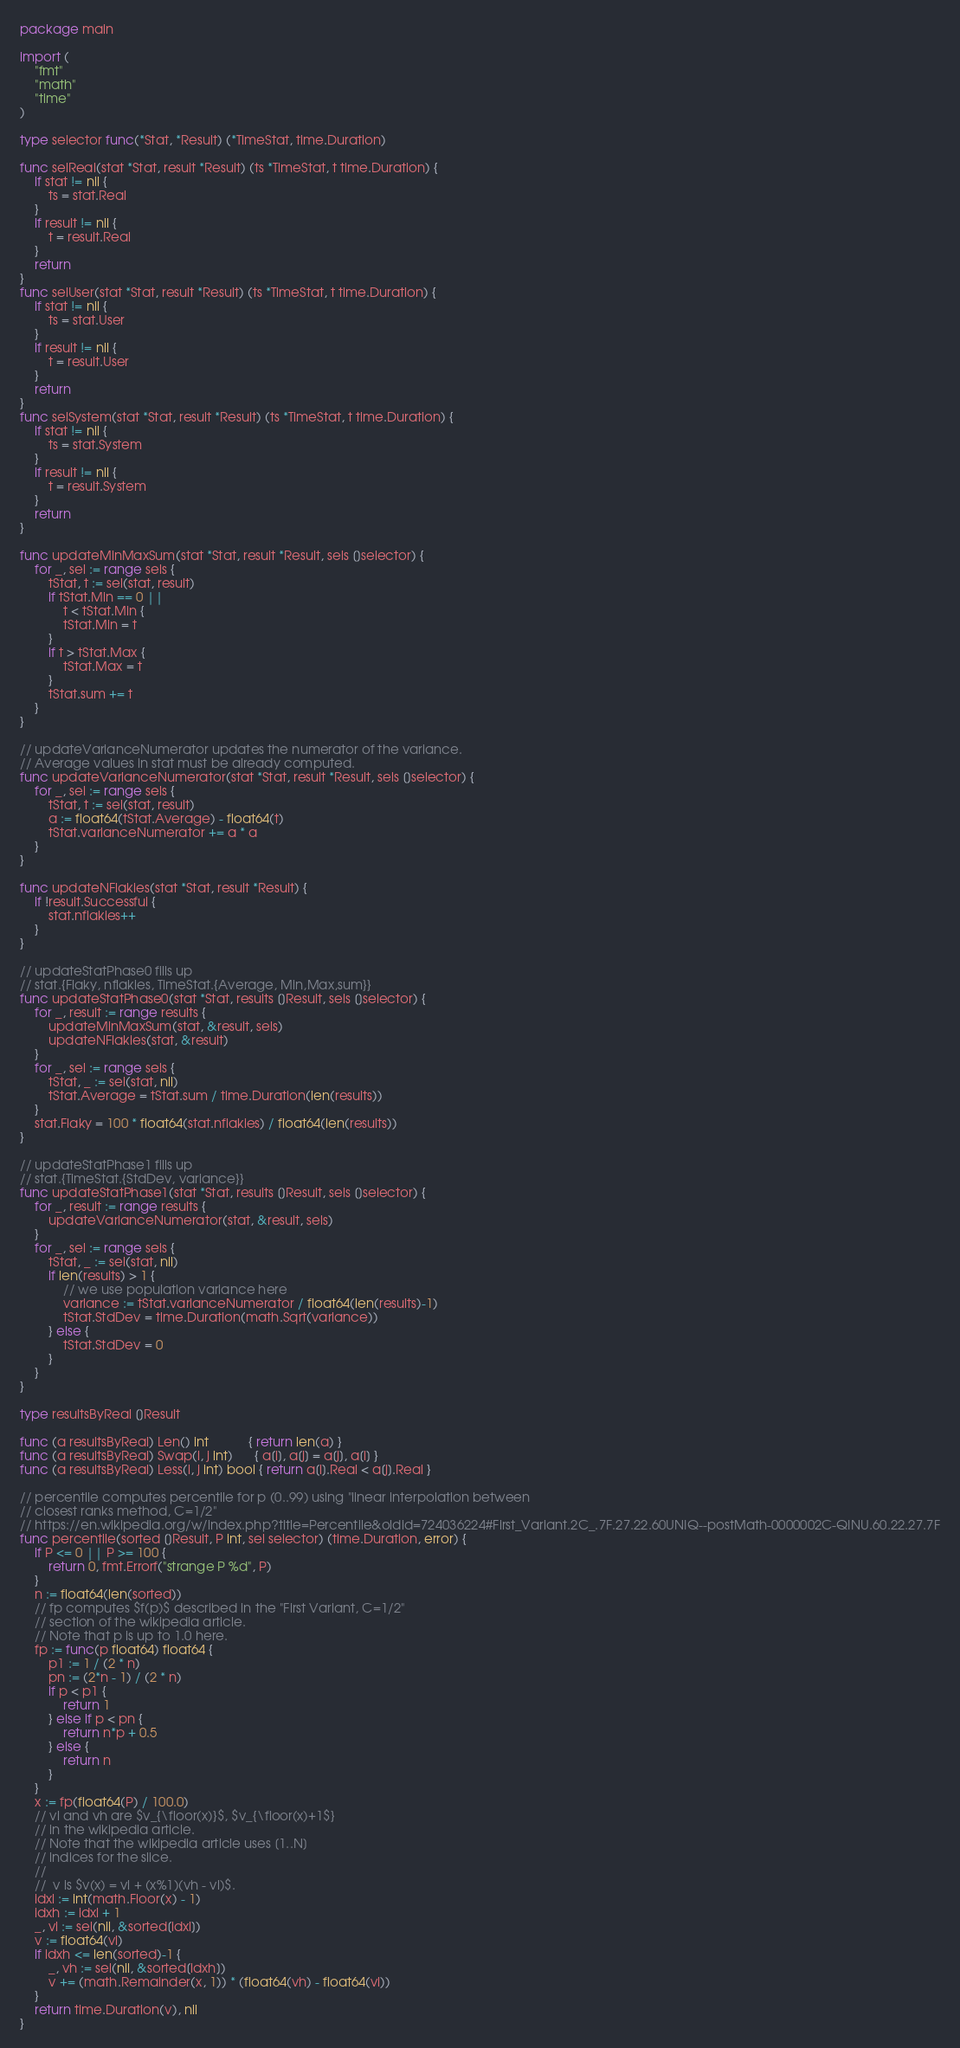<code> <loc_0><loc_0><loc_500><loc_500><_Go_>package main

import (
	"fmt"
	"math"
	"time"
)

type selector func(*Stat, *Result) (*TimeStat, time.Duration)

func selReal(stat *Stat, result *Result) (ts *TimeStat, t time.Duration) {
	if stat != nil {
		ts = stat.Real
	}
	if result != nil {
		t = result.Real
	}
	return
}
func selUser(stat *Stat, result *Result) (ts *TimeStat, t time.Duration) {
	if stat != nil {
		ts = stat.User
	}
	if result != nil {
		t = result.User
	}
	return
}
func selSystem(stat *Stat, result *Result) (ts *TimeStat, t time.Duration) {
	if stat != nil {
		ts = stat.System
	}
	if result != nil {
		t = result.System
	}
	return
}

func updateMinMaxSum(stat *Stat, result *Result, sels []selector) {
	for _, sel := range sels {
		tStat, t := sel(stat, result)
		if tStat.Min == 0 ||
			t < tStat.Min {
			tStat.Min = t
		}
		if t > tStat.Max {
			tStat.Max = t
		}
		tStat.sum += t
	}
}

// updateVarianceNumerator updates the numerator of the variance.
// Average values in stat must be already computed.
func updateVarianceNumerator(stat *Stat, result *Result, sels []selector) {
	for _, sel := range sels {
		tStat, t := sel(stat, result)
		a := float64(tStat.Average) - float64(t)
		tStat.varianceNumerator += a * a
	}
}

func updateNFlakies(stat *Stat, result *Result) {
	if !result.Successful {
		stat.nflakies++
	}
}

// updateStatPhase0 fills up
// stat.{Flaky, nflakies, TimeStat.{Average, Min,Max,sum}}
func updateStatPhase0(stat *Stat, results []Result, sels []selector) {
	for _, result := range results {
		updateMinMaxSum(stat, &result, sels)
		updateNFlakies(stat, &result)
	}
	for _, sel := range sels {
		tStat, _ := sel(stat, nil)
		tStat.Average = tStat.sum / time.Duration(len(results))
	}
	stat.Flaky = 100 * float64(stat.nflakies) / float64(len(results))
}

// updateStatPhase1 fills up
// stat.{TimeStat.{StdDev, variance}}
func updateStatPhase1(stat *Stat, results []Result, sels []selector) {
	for _, result := range results {
		updateVarianceNumerator(stat, &result, sels)
	}
	for _, sel := range sels {
		tStat, _ := sel(stat, nil)
		if len(results) > 1 {
			// we use population variance here
			variance := tStat.varianceNumerator / float64(len(results)-1)
			tStat.StdDev = time.Duration(math.Sqrt(variance))
		} else {
			tStat.StdDev = 0
		}
	}
}

type resultsByReal []Result

func (a resultsByReal) Len() int           { return len(a) }
func (a resultsByReal) Swap(i, j int)      { a[i], a[j] = a[j], a[i] }
func (a resultsByReal) Less(i, j int) bool { return a[i].Real < a[j].Real }

// percentile computes percentile for p (0..99) using "linear interpolation between
// closest ranks method, C=1/2"
// https://en.wikipedia.org/w/index.php?title=Percentile&oldid=724036224#First_Variant.2C_.7F.27.22.60UNIQ--postMath-0000002C-QINU.60.22.27.7F
func percentile(sorted []Result, P int, sel selector) (time.Duration, error) {
	if P <= 0 || P >= 100 {
		return 0, fmt.Errorf("strange P %d", P)
	}
	n := float64(len(sorted))
	// fp computes $f(p)$ described in the "First Variant, C=1/2"
	// section of the wikipedia article.
	// Note that p is up to 1.0 here.
	fp := func(p float64) float64 {
		p1 := 1 / (2 * n)
		pn := (2*n - 1) / (2 * n)
		if p < p1 {
			return 1
		} else if p < pn {
			return n*p + 0.5
		} else {
			return n
		}
	}
	x := fp(float64(P) / 100.0)
	// vl and vh are $v_{\floor(x)}$, $v_{\floor(x)+1$}
	// in the wikipedia article.
	// Note that the wikipedia article uses [1..N]
	// indices for the slice.
	//
	//  v is $v(x) = vl + (x%1)(vh - vl)$.
	idxl := int(math.Floor(x) - 1)
	idxh := idxl + 1
	_, vl := sel(nil, &sorted[idxl])
	v := float64(vl)
	if idxh <= len(sorted)-1 {
		_, vh := sel(nil, &sorted[idxh])
		v += (math.Remainder(x, 1)) * (float64(vh) - float64(vl))
	}
	return time.Duration(v), nil
}
</code> 